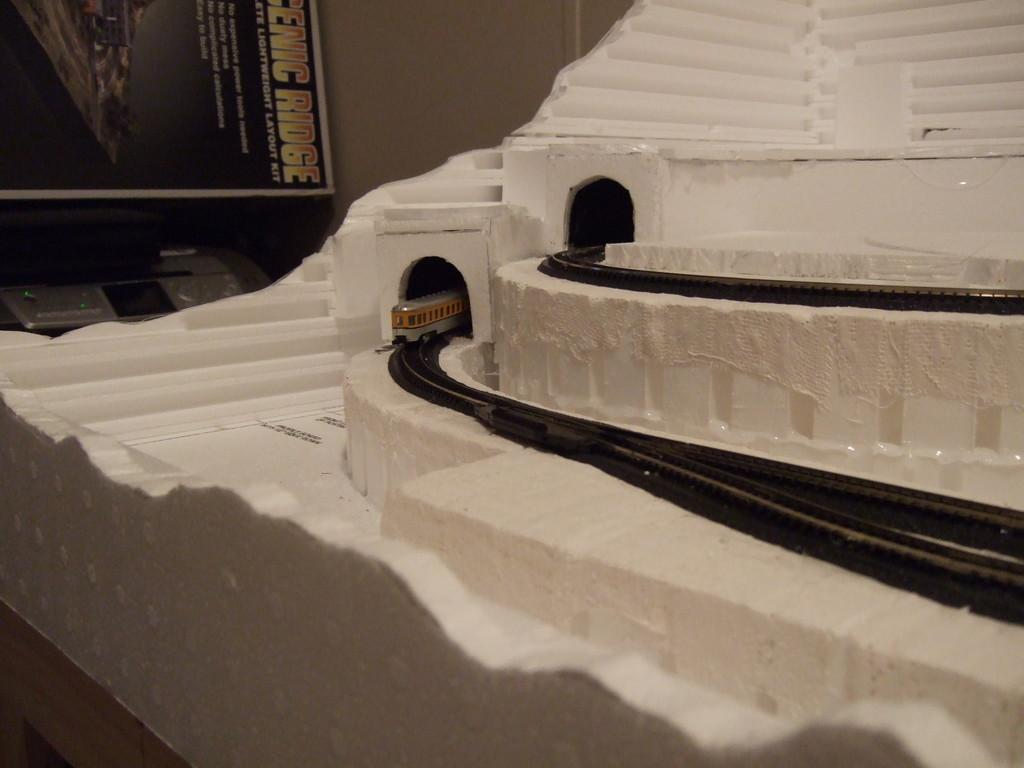What is located on the left side of the image? There is a model train on the left side of the image. What is the model train situated on? The model train is on a railway track. Are there any additional railway tracks in the image? Yes, there is another railway track above the first one. What can be seen in the background of the image? There is a screen and a wall in the background of the image. What is the growth rate of the square in the image? There is no square present in the image, so it is not possible to determine a growth rate. 